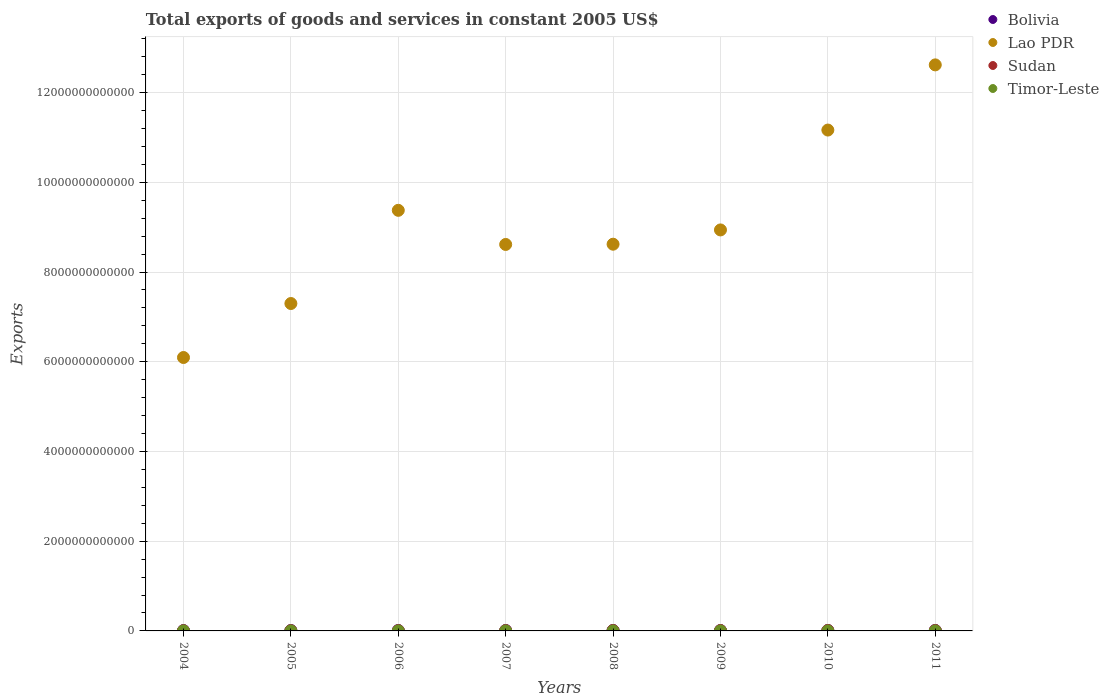Is the number of dotlines equal to the number of legend labels?
Keep it short and to the point. Yes. What is the total exports of goods and services in Bolivia in 2005?
Offer a terse response. 8.91e+09. Across all years, what is the maximum total exports of goods and services in Timor-Leste?
Your answer should be very brief. 9.10e+07. Across all years, what is the minimum total exports of goods and services in Lao PDR?
Your answer should be very brief. 6.09e+12. In which year was the total exports of goods and services in Lao PDR maximum?
Your answer should be very brief. 2011. What is the total total exports of goods and services in Sudan in the graph?
Your answer should be compact. 5.16e+1. What is the difference between the total exports of goods and services in Lao PDR in 2004 and that in 2011?
Make the answer very short. -6.52e+12. What is the difference between the total exports of goods and services in Lao PDR in 2009 and the total exports of goods and services in Sudan in 2008?
Provide a succinct answer. 8.93e+12. What is the average total exports of goods and services in Sudan per year?
Offer a terse response. 6.45e+09. In the year 2006, what is the difference between the total exports of goods and services in Timor-Leste and total exports of goods and services in Lao PDR?
Offer a terse response. -9.37e+12. What is the ratio of the total exports of goods and services in Timor-Leste in 2005 to that in 2008?
Your response must be concise. 0.74. Is the difference between the total exports of goods and services in Timor-Leste in 2007 and 2008 greater than the difference between the total exports of goods and services in Lao PDR in 2007 and 2008?
Offer a very short reply. Yes. What is the difference between the highest and the second highest total exports of goods and services in Timor-Leste?
Your response must be concise. 7.00e+06. What is the difference between the highest and the lowest total exports of goods and services in Timor-Leste?
Ensure brevity in your answer.  4.30e+07. Is the sum of the total exports of goods and services in Bolivia in 2005 and 2006 greater than the maximum total exports of goods and services in Sudan across all years?
Offer a terse response. Yes. Is it the case that in every year, the sum of the total exports of goods and services in Sudan and total exports of goods and services in Timor-Leste  is greater than the total exports of goods and services in Lao PDR?
Make the answer very short. No. Does the total exports of goods and services in Bolivia monotonically increase over the years?
Your response must be concise. No. Is the total exports of goods and services in Lao PDR strictly less than the total exports of goods and services in Bolivia over the years?
Your response must be concise. No. How many years are there in the graph?
Your answer should be compact. 8. What is the difference between two consecutive major ticks on the Y-axis?
Ensure brevity in your answer.  2.00e+12. Are the values on the major ticks of Y-axis written in scientific E-notation?
Offer a very short reply. No. Does the graph contain any zero values?
Provide a succinct answer. No. Does the graph contain grids?
Your response must be concise. Yes. Where does the legend appear in the graph?
Offer a very short reply. Top right. What is the title of the graph?
Ensure brevity in your answer.  Total exports of goods and services in constant 2005 US$. Does "Latvia" appear as one of the legend labels in the graph?
Give a very brief answer. No. What is the label or title of the Y-axis?
Your answer should be compact. Exports. What is the Exports of Bolivia in 2004?
Give a very brief answer. 8.23e+09. What is the Exports of Lao PDR in 2004?
Provide a succinct answer. 6.09e+12. What is the Exports of Sudan in 2004?
Offer a very short reply. 3.97e+09. What is the Exports in Timor-Leste in 2004?
Offer a very short reply. 5.10e+07. What is the Exports in Bolivia in 2005?
Provide a succinct answer. 8.91e+09. What is the Exports in Lao PDR in 2005?
Provide a short and direct response. 7.30e+12. What is the Exports of Sudan in 2005?
Offer a very short reply. 3.98e+09. What is the Exports in Timor-Leste in 2005?
Make the answer very short. 4.80e+07. What is the Exports in Bolivia in 2006?
Give a very brief answer. 9.92e+09. What is the Exports in Lao PDR in 2006?
Offer a terse response. 9.37e+12. What is the Exports of Sudan in 2006?
Provide a short and direct response. 5.32e+09. What is the Exports of Timor-Leste in 2006?
Your response must be concise. 4.90e+07. What is the Exports in Bolivia in 2007?
Provide a short and direct response. 1.02e+1. What is the Exports of Lao PDR in 2007?
Provide a succinct answer. 8.61e+12. What is the Exports in Sudan in 2007?
Give a very brief answer. 6.55e+09. What is the Exports in Timor-Leste in 2007?
Your response must be concise. 6.40e+07. What is the Exports in Bolivia in 2008?
Give a very brief answer. 1.05e+1. What is the Exports of Lao PDR in 2008?
Your response must be concise. 8.62e+12. What is the Exports in Sudan in 2008?
Keep it short and to the point. 8.05e+09. What is the Exports of Timor-Leste in 2008?
Make the answer very short. 6.50e+07. What is the Exports of Bolivia in 2009?
Your answer should be compact. 9.33e+09. What is the Exports in Lao PDR in 2009?
Make the answer very short. 8.94e+12. What is the Exports in Sudan in 2009?
Provide a succinct answer. 7.73e+09. What is the Exports of Timor-Leste in 2009?
Provide a succinct answer. 7.70e+07. What is the Exports of Bolivia in 2010?
Provide a short and direct response. 1.02e+1. What is the Exports of Lao PDR in 2010?
Give a very brief answer. 1.12e+13. What is the Exports of Sudan in 2010?
Your response must be concise. 8.13e+09. What is the Exports of Timor-Leste in 2010?
Provide a short and direct response. 9.10e+07. What is the Exports of Bolivia in 2011?
Offer a very short reply. 1.07e+1. What is the Exports in Lao PDR in 2011?
Your response must be concise. 1.26e+13. What is the Exports in Sudan in 2011?
Offer a very short reply. 7.86e+09. What is the Exports of Timor-Leste in 2011?
Offer a very short reply. 8.40e+07. Across all years, what is the maximum Exports of Bolivia?
Offer a terse response. 1.07e+1. Across all years, what is the maximum Exports of Lao PDR?
Your answer should be compact. 1.26e+13. Across all years, what is the maximum Exports of Sudan?
Provide a succinct answer. 8.13e+09. Across all years, what is the maximum Exports in Timor-Leste?
Offer a terse response. 9.10e+07. Across all years, what is the minimum Exports of Bolivia?
Provide a succinct answer. 8.23e+09. Across all years, what is the minimum Exports of Lao PDR?
Give a very brief answer. 6.09e+12. Across all years, what is the minimum Exports in Sudan?
Make the answer very short. 3.97e+09. Across all years, what is the minimum Exports in Timor-Leste?
Make the answer very short. 4.80e+07. What is the total Exports in Bolivia in the graph?
Offer a very short reply. 7.81e+1. What is the total Exports in Lao PDR in the graph?
Give a very brief answer. 7.27e+13. What is the total Exports in Sudan in the graph?
Your answer should be very brief. 5.16e+1. What is the total Exports in Timor-Leste in the graph?
Provide a succinct answer. 5.29e+08. What is the difference between the Exports of Bolivia in 2004 and that in 2005?
Give a very brief answer. -6.86e+08. What is the difference between the Exports in Lao PDR in 2004 and that in 2005?
Make the answer very short. -1.20e+12. What is the difference between the Exports of Sudan in 2004 and that in 2005?
Keep it short and to the point. -1.63e+07. What is the difference between the Exports of Timor-Leste in 2004 and that in 2005?
Your answer should be compact. 3.00e+06. What is the difference between the Exports of Bolivia in 2004 and that in 2006?
Give a very brief answer. -1.70e+09. What is the difference between the Exports in Lao PDR in 2004 and that in 2006?
Ensure brevity in your answer.  -3.28e+12. What is the difference between the Exports in Sudan in 2004 and that in 2006?
Your answer should be very brief. -1.36e+09. What is the difference between the Exports in Bolivia in 2004 and that in 2007?
Your answer should be very brief. -2.00e+09. What is the difference between the Exports of Lao PDR in 2004 and that in 2007?
Your answer should be compact. -2.52e+12. What is the difference between the Exports of Sudan in 2004 and that in 2007?
Give a very brief answer. -2.58e+09. What is the difference between the Exports of Timor-Leste in 2004 and that in 2007?
Your response must be concise. -1.30e+07. What is the difference between the Exports in Bolivia in 2004 and that in 2008?
Provide a succinct answer. -2.23e+09. What is the difference between the Exports of Lao PDR in 2004 and that in 2008?
Your response must be concise. -2.53e+12. What is the difference between the Exports in Sudan in 2004 and that in 2008?
Offer a terse response. -4.09e+09. What is the difference between the Exports in Timor-Leste in 2004 and that in 2008?
Offer a terse response. -1.40e+07. What is the difference between the Exports of Bolivia in 2004 and that in 2009?
Ensure brevity in your answer.  -1.10e+09. What is the difference between the Exports of Lao PDR in 2004 and that in 2009?
Keep it short and to the point. -2.84e+12. What is the difference between the Exports of Sudan in 2004 and that in 2009?
Offer a terse response. -3.77e+09. What is the difference between the Exports in Timor-Leste in 2004 and that in 2009?
Offer a terse response. -2.60e+07. What is the difference between the Exports in Bolivia in 2004 and that in 2010?
Your response must be concise. -2.02e+09. What is the difference between the Exports in Lao PDR in 2004 and that in 2010?
Your answer should be compact. -5.07e+12. What is the difference between the Exports of Sudan in 2004 and that in 2010?
Your response must be concise. -4.16e+09. What is the difference between the Exports in Timor-Leste in 2004 and that in 2010?
Your response must be concise. -4.00e+07. What is the difference between the Exports in Bolivia in 2004 and that in 2011?
Keep it short and to the point. -2.49e+09. What is the difference between the Exports of Lao PDR in 2004 and that in 2011?
Provide a succinct answer. -6.52e+12. What is the difference between the Exports of Sudan in 2004 and that in 2011?
Keep it short and to the point. -3.89e+09. What is the difference between the Exports in Timor-Leste in 2004 and that in 2011?
Keep it short and to the point. -3.30e+07. What is the difference between the Exports of Bolivia in 2005 and that in 2006?
Your answer should be very brief. -1.01e+09. What is the difference between the Exports of Lao PDR in 2005 and that in 2006?
Your answer should be compact. -2.08e+12. What is the difference between the Exports of Sudan in 2005 and that in 2006?
Ensure brevity in your answer.  -1.34e+09. What is the difference between the Exports in Timor-Leste in 2005 and that in 2006?
Keep it short and to the point. -1.00e+06. What is the difference between the Exports of Bolivia in 2005 and that in 2007?
Make the answer very short. -1.32e+09. What is the difference between the Exports in Lao PDR in 2005 and that in 2007?
Your answer should be very brief. -1.32e+12. What is the difference between the Exports in Sudan in 2005 and that in 2007?
Give a very brief answer. -2.57e+09. What is the difference between the Exports in Timor-Leste in 2005 and that in 2007?
Keep it short and to the point. -1.60e+07. What is the difference between the Exports in Bolivia in 2005 and that in 2008?
Your answer should be compact. -1.54e+09. What is the difference between the Exports of Lao PDR in 2005 and that in 2008?
Give a very brief answer. -1.32e+12. What is the difference between the Exports of Sudan in 2005 and that in 2008?
Offer a very short reply. -4.07e+09. What is the difference between the Exports in Timor-Leste in 2005 and that in 2008?
Keep it short and to the point. -1.70e+07. What is the difference between the Exports in Bolivia in 2005 and that in 2009?
Provide a succinct answer. -4.15e+08. What is the difference between the Exports in Lao PDR in 2005 and that in 2009?
Offer a terse response. -1.64e+12. What is the difference between the Exports of Sudan in 2005 and that in 2009?
Your response must be concise. -3.75e+09. What is the difference between the Exports in Timor-Leste in 2005 and that in 2009?
Provide a short and direct response. -2.90e+07. What is the difference between the Exports in Bolivia in 2005 and that in 2010?
Make the answer very short. -1.33e+09. What is the difference between the Exports in Lao PDR in 2005 and that in 2010?
Provide a succinct answer. -3.87e+12. What is the difference between the Exports in Sudan in 2005 and that in 2010?
Keep it short and to the point. -4.15e+09. What is the difference between the Exports of Timor-Leste in 2005 and that in 2010?
Provide a short and direct response. -4.30e+07. What is the difference between the Exports of Bolivia in 2005 and that in 2011?
Ensure brevity in your answer.  -1.81e+09. What is the difference between the Exports of Lao PDR in 2005 and that in 2011?
Offer a very short reply. -5.32e+12. What is the difference between the Exports of Sudan in 2005 and that in 2011?
Offer a very short reply. -3.88e+09. What is the difference between the Exports of Timor-Leste in 2005 and that in 2011?
Make the answer very short. -3.60e+07. What is the difference between the Exports in Bolivia in 2006 and that in 2007?
Offer a terse response. -3.07e+08. What is the difference between the Exports in Lao PDR in 2006 and that in 2007?
Your answer should be compact. 7.61e+11. What is the difference between the Exports of Sudan in 2006 and that in 2007?
Offer a terse response. -1.23e+09. What is the difference between the Exports of Timor-Leste in 2006 and that in 2007?
Ensure brevity in your answer.  -1.50e+07. What is the difference between the Exports of Bolivia in 2006 and that in 2008?
Make the answer very short. -5.29e+08. What is the difference between the Exports of Lao PDR in 2006 and that in 2008?
Provide a succinct answer. 7.55e+11. What is the difference between the Exports in Sudan in 2006 and that in 2008?
Make the answer very short. -2.73e+09. What is the difference between the Exports of Timor-Leste in 2006 and that in 2008?
Offer a very short reply. -1.60e+07. What is the difference between the Exports of Bolivia in 2006 and that in 2009?
Your response must be concise. 5.95e+08. What is the difference between the Exports in Lao PDR in 2006 and that in 2009?
Offer a terse response. 4.37e+11. What is the difference between the Exports in Sudan in 2006 and that in 2009?
Offer a terse response. -2.41e+09. What is the difference between the Exports in Timor-Leste in 2006 and that in 2009?
Offer a very short reply. -2.80e+07. What is the difference between the Exports of Bolivia in 2006 and that in 2010?
Give a very brief answer. -3.24e+08. What is the difference between the Exports of Lao PDR in 2006 and that in 2010?
Provide a short and direct response. -1.79e+12. What is the difference between the Exports in Sudan in 2006 and that in 2010?
Provide a succinct answer. -2.81e+09. What is the difference between the Exports in Timor-Leste in 2006 and that in 2010?
Your answer should be compact. -4.20e+07. What is the difference between the Exports of Bolivia in 2006 and that in 2011?
Provide a short and direct response. -7.95e+08. What is the difference between the Exports of Lao PDR in 2006 and that in 2011?
Ensure brevity in your answer.  -3.24e+12. What is the difference between the Exports in Sudan in 2006 and that in 2011?
Keep it short and to the point. -2.54e+09. What is the difference between the Exports of Timor-Leste in 2006 and that in 2011?
Provide a succinct answer. -3.50e+07. What is the difference between the Exports in Bolivia in 2007 and that in 2008?
Provide a short and direct response. -2.22e+08. What is the difference between the Exports in Lao PDR in 2007 and that in 2008?
Your response must be concise. -5.55e+09. What is the difference between the Exports in Sudan in 2007 and that in 2008?
Ensure brevity in your answer.  -1.51e+09. What is the difference between the Exports in Bolivia in 2007 and that in 2009?
Offer a very short reply. 9.02e+08. What is the difference between the Exports of Lao PDR in 2007 and that in 2009?
Provide a short and direct response. -3.24e+11. What is the difference between the Exports of Sudan in 2007 and that in 2009?
Provide a succinct answer. -1.18e+09. What is the difference between the Exports in Timor-Leste in 2007 and that in 2009?
Your answer should be very brief. -1.30e+07. What is the difference between the Exports in Bolivia in 2007 and that in 2010?
Your answer should be compact. -1.73e+07. What is the difference between the Exports of Lao PDR in 2007 and that in 2010?
Provide a short and direct response. -2.55e+12. What is the difference between the Exports in Sudan in 2007 and that in 2010?
Give a very brief answer. -1.58e+09. What is the difference between the Exports of Timor-Leste in 2007 and that in 2010?
Give a very brief answer. -2.70e+07. What is the difference between the Exports of Bolivia in 2007 and that in 2011?
Keep it short and to the point. -4.88e+08. What is the difference between the Exports in Lao PDR in 2007 and that in 2011?
Keep it short and to the point. -4.00e+12. What is the difference between the Exports of Sudan in 2007 and that in 2011?
Your answer should be very brief. -1.31e+09. What is the difference between the Exports of Timor-Leste in 2007 and that in 2011?
Your answer should be very brief. -2.00e+07. What is the difference between the Exports of Bolivia in 2008 and that in 2009?
Offer a very short reply. 1.12e+09. What is the difference between the Exports in Lao PDR in 2008 and that in 2009?
Keep it short and to the point. -3.18e+11. What is the difference between the Exports in Sudan in 2008 and that in 2009?
Your answer should be very brief. 3.23e+08. What is the difference between the Exports in Timor-Leste in 2008 and that in 2009?
Your answer should be compact. -1.20e+07. What is the difference between the Exports of Bolivia in 2008 and that in 2010?
Keep it short and to the point. 2.05e+08. What is the difference between the Exports of Lao PDR in 2008 and that in 2010?
Offer a very short reply. -2.54e+12. What is the difference between the Exports in Sudan in 2008 and that in 2010?
Ensure brevity in your answer.  -7.33e+07. What is the difference between the Exports in Timor-Leste in 2008 and that in 2010?
Provide a succinct answer. -2.60e+07. What is the difference between the Exports in Bolivia in 2008 and that in 2011?
Provide a succinct answer. -2.66e+08. What is the difference between the Exports in Lao PDR in 2008 and that in 2011?
Offer a very short reply. -4.00e+12. What is the difference between the Exports of Sudan in 2008 and that in 2011?
Ensure brevity in your answer.  1.95e+08. What is the difference between the Exports of Timor-Leste in 2008 and that in 2011?
Make the answer very short. -1.90e+07. What is the difference between the Exports of Bolivia in 2009 and that in 2010?
Your answer should be compact. -9.19e+08. What is the difference between the Exports of Lao PDR in 2009 and that in 2010?
Your response must be concise. -2.23e+12. What is the difference between the Exports of Sudan in 2009 and that in 2010?
Provide a succinct answer. -3.97e+08. What is the difference between the Exports in Timor-Leste in 2009 and that in 2010?
Offer a very short reply. -1.40e+07. What is the difference between the Exports in Bolivia in 2009 and that in 2011?
Your response must be concise. -1.39e+09. What is the difference between the Exports of Lao PDR in 2009 and that in 2011?
Keep it short and to the point. -3.68e+12. What is the difference between the Exports in Sudan in 2009 and that in 2011?
Provide a short and direct response. -1.28e+08. What is the difference between the Exports of Timor-Leste in 2009 and that in 2011?
Provide a short and direct response. -7.00e+06. What is the difference between the Exports of Bolivia in 2010 and that in 2011?
Your response must be concise. -4.71e+08. What is the difference between the Exports of Lao PDR in 2010 and that in 2011?
Keep it short and to the point. -1.45e+12. What is the difference between the Exports of Sudan in 2010 and that in 2011?
Your answer should be very brief. 2.69e+08. What is the difference between the Exports in Bolivia in 2004 and the Exports in Lao PDR in 2005?
Offer a very short reply. -7.29e+12. What is the difference between the Exports of Bolivia in 2004 and the Exports of Sudan in 2005?
Offer a terse response. 4.25e+09. What is the difference between the Exports of Bolivia in 2004 and the Exports of Timor-Leste in 2005?
Give a very brief answer. 8.18e+09. What is the difference between the Exports in Lao PDR in 2004 and the Exports in Sudan in 2005?
Your answer should be compact. 6.09e+12. What is the difference between the Exports of Lao PDR in 2004 and the Exports of Timor-Leste in 2005?
Your answer should be compact. 6.09e+12. What is the difference between the Exports in Sudan in 2004 and the Exports in Timor-Leste in 2005?
Provide a short and direct response. 3.92e+09. What is the difference between the Exports in Bolivia in 2004 and the Exports in Lao PDR in 2006?
Provide a short and direct response. -9.37e+12. What is the difference between the Exports in Bolivia in 2004 and the Exports in Sudan in 2006?
Make the answer very short. 2.91e+09. What is the difference between the Exports of Bolivia in 2004 and the Exports of Timor-Leste in 2006?
Your response must be concise. 8.18e+09. What is the difference between the Exports of Lao PDR in 2004 and the Exports of Sudan in 2006?
Your answer should be compact. 6.09e+12. What is the difference between the Exports in Lao PDR in 2004 and the Exports in Timor-Leste in 2006?
Give a very brief answer. 6.09e+12. What is the difference between the Exports in Sudan in 2004 and the Exports in Timor-Leste in 2006?
Your response must be concise. 3.92e+09. What is the difference between the Exports of Bolivia in 2004 and the Exports of Lao PDR in 2007?
Provide a succinct answer. -8.61e+12. What is the difference between the Exports of Bolivia in 2004 and the Exports of Sudan in 2007?
Provide a short and direct response. 1.68e+09. What is the difference between the Exports in Bolivia in 2004 and the Exports in Timor-Leste in 2007?
Keep it short and to the point. 8.16e+09. What is the difference between the Exports of Lao PDR in 2004 and the Exports of Sudan in 2007?
Provide a succinct answer. 6.09e+12. What is the difference between the Exports in Lao PDR in 2004 and the Exports in Timor-Leste in 2007?
Your answer should be very brief. 6.09e+12. What is the difference between the Exports of Sudan in 2004 and the Exports of Timor-Leste in 2007?
Your response must be concise. 3.90e+09. What is the difference between the Exports of Bolivia in 2004 and the Exports of Lao PDR in 2008?
Offer a very short reply. -8.61e+12. What is the difference between the Exports of Bolivia in 2004 and the Exports of Sudan in 2008?
Ensure brevity in your answer.  1.74e+08. What is the difference between the Exports in Bolivia in 2004 and the Exports in Timor-Leste in 2008?
Your answer should be compact. 8.16e+09. What is the difference between the Exports of Lao PDR in 2004 and the Exports of Sudan in 2008?
Your answer should be compact. 6.09e+12. What is the difference between the Exports in Lao PDR in 2004 and the Exports in Timor-Leste in 2008?
Your response must be concise. 6.09e+12. What is the difference between the Exports of Sudan in 2004 and the Exports of Timor-Leste in 2008?
Your answer should be very brief. 3.90e+09. What is the difference between the Exports in Bolivia in 2004 and the Exports in Lao PDR in 2009?
Provide a succinct answer. -8.93e+12. What is the difference between the Exports in Bolivia in 2004 and the Exports in Sudan in 2009?
Give a very brief answer. 4.97e+08. What is the difference between the Exports in Bolivia in 2004 and the Exports in Timor-Leste in 2009?
Provide a short and direct response. 8.15e+09. What is the difference between the Exports in Lao PDR in 2004 and the Exports in Sudan in 2009?
Ensure brevity in your answer.  6.09e+12. What is the difference between the Exports of Lao PDR in 2004 and the Exports of Timor-Leste in 2009?
Offer a very short reply. 6.09e+12. What is the difference between the Exports of Sudan in 2004 and the Exports of Timor-Leste in 2009?
Your response must be concise. 3.89e+09. What is the difference between the Exports of Bolivia in 2004 and the Exports of Lao PDR in 2010?
Make the answer very short. -1.12e+13. What is the difference between the Exports in Bolivia in 2004 and the Exports in Sudan in 2010?
Make the answer very short. 1.00e+08. What is the difference between the Exports of Bolivia in 2004 and the Exports of Timor-Leste in 2010?
Give a very brief answer. 8.14e+09. What is the difference between the Exports of Lao PDR in 2004 and the Exports of Sudan in 2010?
Give a very brief answer. 6.09e+12. What is the difference between the Exports of Lao PDR in 2004 and the Exports of Timor-Leste in 2010?
Make the answer very short. 6.09e+12. What is the difference between the Exports of Sudan in 2004 and the Exports of Timor-Leste in 2010?
Make the answer very short. 3.87e+09. What is the difference between the Exports of Bolivia in 2004 and the Exports of Lao PDR in 2011?
Offer a very short reply. -1.26e+13. What is the difference between the Exports in Bolivia in 2004 and the Exports in Sudan in 2011?
Your response must be concise. 3.69e+08. What is the difference between the Exports in Bolivia in 2004 and the Exports in Timor-Leste in 2011?
Ensure brevity in your answer.  8.14e+09. What is the difference between the Exports in Lao PDR in 2004 and the Exports in Sudan in 2011?
Your response must be concise. 6.09e+12. What is the difference between the Exports of Lao PDR in 2004 and the Exports of Timor-Leste in 2011?
Your answer should be very brief. 6.09e+12. What is the difference between the Exports of Sudan in 2004 and the Exports of Timor-Leste in 2011?
Ensure brevity in your answer.  3.88e+09. What is the difference between the Exports in Bolivia in 2005 and the Exports in Lao PDR in 2006?
Offer a terse response. -9.37e+12. What is the difference between the Exports of Bolivia in 2005 and the Exports of Sudan in 2006?
Give a very brief answer. 3.59e+09. What is the difference between the Exports of Bolivia in 2005 and the Exports of Timor-Leste in 2006?
Offer a very short reply. 8.87e+09. What is the difference between the Exports in Lao PDR in 2005 and the Exports in Sudan in 2006?
Your response must be concise. 7.29e+12. What is the difference between the Exports of Lao PDR in 2005 and the Exports of Timor-Leste in 2006?
Give a very brief answer. 7.30e+12. What is the difference between the Exports of Sudan in 2005 and the Exports of Timor-Leste in 2006?
Give a very brief answer. 3.93e+09. What is the difference between the Exports of Bolivia in 2005 and the Exports of Lao PDR in 2007?
Make the answer very short. -8.61e+12. What is the difference between the Exports of Bolivia in 2005 and the Exports of Sudan in 2007?
Offer a terse response. 2.37e+09. What is the difference between the Exports of Bolivia in 2005 and the Exports of Timor-Leste in 2007?
Provide a succinct answer. 8.85e+09. What is the difference between the Exports of Lao PDR in 2005 and the Exports of Sudan in 2007?
Your answer should be compact. 7.29e+12. What is the difference between the Exports in Lao PDR in 2005 and the Exports in Timor-Leste in 2007?
Offer a very short reply. 7.30e+12. What is the difference between the Exports in Sudan in 2005 and the Exports in Timor-Leste in 2007?
Make the answer very short. 3.92e+09. What is the difference between the Exports of Bolivia in 2005 and the Exports of Lao PDR in 2008?
Your response must be concise. -8.61e+12. What is the difference between the Exports in Bolivia in 2005 and the Exports in Sudan in 2008?
Your answer should be compact. 8.60e+08. What is the difference between the Exports of Bolivia in 2005 and the Exports of Timor-Leste in 2008?
Keep it short and to the point. 8.85e+09. What is the difference between the Exports in Lao PDR in 2005 and the Exports in Sudan in 2008?
Give a very brief answer. 7.29e+12. What is the difference between the Exports of Lao PDR in 2005 and the Exports of Timor-Leste in 2008?
Your answer should be very brief. 7.30e+12. What is the difference between the Exports of Sudan in 2005 and the Exports of Timor-Leste in 2008?
Ensure brevity in your answer.  3.92e+09. What is the difference between the Exports of Bolivia in 2005 and the Exports of Lao PDR in 2009?
Provide a short and direct response. -8.93e+12. What is the difference between the Exports of Bolivia in 2005 and the Exports of Sudan in 2009?
Give a very brief answer. 1.18e+09. What is the difference between the Exports in Bolivia in 2005 and the Exports in Timor-Leste in 2009?
Offer a terse response. 8.84e+09. What is the difference between the Exports in Lao PDR in 2005 and the Exports in Sudan in 2009?
Offer a terse response. 7.29e+12. What is the difference between the Exports of Lao PDR in 2005 and the Exports of Timor-Leste in 2009?
Ensure brevity in your answer.  7.30e+12. What is the difference between the Exports in Sudan in 2005 and the Exports in Timor-Leste in 2009?
Offer a terse response. 3.90e+09. What is the difference between the Exports in Bolivia in 2005 and the Exports in Lao PDR in 2010?
Provide a short and direct response. -1.12e+13. What is the difference between the Exports of Bolivia in 2005 and the Exports of Sudan in 2010?
Your answer should be very brief. 7.86e+08. What is the difference between the Exports in Bolivia in 2005 and the Exports in Timor-Leste in 2010?
Your answer should be very brief. 8.82e+09. What is the difference between the Exports in Lao PDR in 2005 and the Exports in Sudan in 2010?
Your answer should be compact. 7.29e+12. What is the difference between the Exports in Lao PDR in 2005 and the Exports in Timor-Leste in 2010?
Your answer should be compact. 7.30e+12. What is the difference between the Exports in Sudan in 2005 and the Exports in Timor-Leste in 2010?
Give a very brief answer. 3.89e+09. What is the difference between the Exports in Bolivia in 2005 and the Exports in Lao PDR in 2011?
Provide a short and direct response. -1.26e+13. What is the difference between the Exports of Bolivia in 2005 and the Exports of Sudan in 2011?
Ensure brevity in your answer.  1.05e+09. What is the difference between the Exports in Bolivia in 2005 and the Exports in Timor-Leste in 2011?
Provide a succinct answer. 8.83e+09. What is the difference between the Exports of Lao PDR in 2005 and the Exports of Sudan in 2011?
Your response must be concise. 7.29e+12. What is the difference between the Exports in Lao PDR in 2005 and the Exports in Timor-Leste in 2011?
Make the answer very short. 7.30e+12. What is the difference between the Exports in Sudan in 2005 and the Exports in Timor-Leste in 2011?
Give a very brief answer. 3.90e+09. What is the difference between the Exports in Bolivia in 2006 and the Exports in Lao PDR in 2007?
Provide a short and direct response. -8.60e+12. What is the difference between the Exports in Bolivia in 2006 and the Exports in Sudan in 2007?
Keep it short and to the point. 3.38e+09. What is the difference between the Exports of Bolivia in 2006 and the Exports of Timor-Leste in 2007?
Offer a terse response. 9.86e+09. What is the difference between the Exports in Lao PDR in 2006 and the Exports in Sudan in 2007?
Keep it short and to the point. 9.37e+12. What is the difference between the Exports in Lao PDR in 2006 and the Exports in Timor-Leste in 2007?
Ensure brevity in your answer.  9.37e+12. What is the difference between the Exports of Sudan in 2006 and the Exports of Timor-Leste in 2007?
Provide a succinct answer. 5.26e+09. What is the difference between the Exports in Bolivia in 2006 and the Exports in Lao PDR in 2008?
Provide a succinct answer. -8.61e+12. What is the difference between the Exports of Bolivia in 2006 and the Exports of Sudan in 2008?
Offer a very short reply. 1.87e+09. What is the difference between the Exports of Bolivia in 2006 and the Exports of Timor-Leste in 2008?
Provide a succinct answer. 9.86e+09. What is the difference between the Exports of Lao PDR in 2006 and the Exports of Sudan in 2008?
Your answer should be compact. 9.37e+12. What is the difference between the Exports in Lao PDR in 2006 and the Exports in Timor-Leste in 2008?
Offer a very short reply. 9.37e+12. What is the difference between the Exports in Sudan in 2006 and the Exports in Timor-Leste in 2008?
Give a very brief answer. 5.26e+09. What is the difference between the Exports of Bolivia in 2006 and the Exports of Lao PDR in 2009?
Provide a succinct answer. -8.93e+12. What is the difference between the Exports in Bolivia in 2006 and the Exports in Sudan in 2009?
Ensure brevity in your answer.  2.19e+09. What is the difference between the Exports in Bolivia in 2006 and the Exports in Timor-Leste in 2009?
Your answer should be compact. 9.85e+09. What is the difference between the Exports of Lao PDR in 2006 and the Exports of Sudan in 2009?
Your answer should be very brief. 9.37e+12. What is the difference between the Exports of Lao PDR in 2006 and the Exports of Timor-Leste in 2009?
Ensure brevity in your answer.  9.37e+12. What is the difference between the Exports of Sudan in 2006 and the Exports of Timor-Leste in 2009?
Give a very brief answer. 5.24e+09. What is the difference between the Exports in Bolivia in 2006 and the Exports in Lao PDR in 2010?
Provide a succinct answer. -1.12e+13. What is the difference between the Exports of Bolivia in 2006 and the Exports of Sudan in 2010?
Offer a very short reply. 1.80e+09. What is the difference between the Exports of Bolivia in 2006 and the Exports of Timor-Leste in 2010?
Your answer should be very brief. 9.83e+09. What is the difference between the Exports in Lao PDR in 2006 and the Exports in Sudan in 2010?
Make the answer very short. 9.37e+12. What is the difference between the Exports of Lao PDR in 2006 and the Exports of Timor-Leste in 2010?
Provide a succinct answer. 9.37e+12. What is the difference between the Exports of Sudan in 2006 and the Exports of Timor-Leste in 2010?
Provide a short and direct response. 5.23e+09. What is the difference between the Exports in Bolivia in 2006 and the Exports in Lao PDR in 2011?
Offer a very short reply. -1.26e+13. What is the difference between the Exports of Bolivia in 2006 and the Exports of Sudan in 2011?
Provide a succinct answer. 2.07e+09. What is the difference between the Exports in Bolivia in 2006 and the Exports in Timor-Leste in 2011?
Provide a succinct answer. 9.84e+09. What is the difference between the Exports in Lao PDR in 2006 and the Exports in Sudan in 2011?
Your answer should be very brief. 9.37e+12. What is the difference between the Exports in Lao PDR in 2006 and the Exports in Timor-Leste in 2011?
Provide a succinct answer. 9.37e+12. What is the difference between the Exports in Sudan in 2006 and the Exports in Timor-Leste in 2011?
Offer a terse response. 5.24e+09. What is the difference between the Exports in Bolivia in 2007 and the Exports in Lao PDR in 2008?
Ensure brevity in your answer.  -8.61e+12. What is the difference between the Exports of Bolivia in 2007 and the Exports of Sudan in 2008?
Provide a short and direct response. 2.18e+09. What is the difference between the Exports in Bolivia in 2007 and the Exports in Timor-Leste in 2008?
Make the answer very short. 1.02e+1. What is the difference between the Exports of Lao PDR in 2007 and the Exports of Sudan in 2008?
Provide a succinct answer. 8.61e+12. What is the difference between the Exports of Lao PDR in 2007 and the Exports of Timor-Leste in 2008?
Make the answer very short. 8.61e+12. What is the difference between the Exports in Sudan in 2007 and the Exports in Timor-Leste in 2008?
Your response must be concise. 6.48e+09. What is the difference between the Exports of Bolivia in 2007 and the Exports of Lao PDR in 2009?
Keep it short and to the point. -8.93e+12. What is the difference between the Exports of Bolivia in 2007 and the Exports of Sudan in 2009?
Provide a short and direct response. 2.50e+09. What is the difference between the Exports in Bolivia in 2007 and the Exports in Timor-Leste in 2009?
Make the answer very short. 1.02e+1. What is the difference between the Exports in Lao PDR in 2007 and the Exports in Sudan in 2009?
Keep it short and to the point. 8.61e+12. What is the difference between the Exports of Lao PDR in 2007 and the Exports of Timor-Leste in 2009?
Keep it short and to the point. 8.61e+12. What is the difference between the Exports in Sudan in 2007 and the Exports in Timor-Leste in 2009?
Make the answer very short. 6.47e+09. What is the difference between the Exports in Bolivia in 2007 and the Exports in Lao PDR in 2010?
Ensure brevity in your answer.  -1.12e+13. What is the difference between the Exports in Bolivia in 2007 and the Exports in Sudan in 2010?
Offer a terse response. 2.10e+09. What is the difference between the Exports of Bolivia in 2007 and the Exports of Timor-Leste in 2010?
Keep it short and to the point. 1.01e+1. What is the difference between the Exports in Lao PDR in 2007 and the Exports in Sudan in 2010?
Your answer should be compact. 8.61e+12. What is the difference between the Exports of Lao PDR in 2007 and the Exports of Timor-Leste in 2010?
Offer a very short reply. 8.61e+12. What is the difference between the Exports in Sudan in 2007 and the Exports in Timor-Leste in 2010?
Ensure brevity in your answer.  6.46e+09. What is the difference between the Exports in Bolivia in 2007 and the Exports in Lao PDR in 2011?
Ensure brevity in your answer.  -1.26e+13. What is the difference between the Exports of Bolivia in 2007 and the Exports of Sudan in 2011?
Your answer should be very brief. 2.37e+09. What is the difference between the Exports of Bolivia in 2007 and the Exports of Timor-Leste in 2011?
Provide a short and direct response. 1.01e+1. What is the difference between the Exports of Lao PDR in 2007 and the Exports of Sudan in 2011?
Your answer should be compact. 8.61e+12. What is the difference between the Exports in Lao PDR in 2007 and the Exports in Timor-Leste in 2011?
Give a very brief answer. 8.61e+12. What is the difference between the Exports in Sudan in 2007 and the Exports in Timor-Leste in 2011?
Offer a very short reply. 6.46e+09. What is the difference between the Exports of Bolivia in 2008 and the Exports of Lao PDR in 2009?
Make the answer very short. -8.93e+12. What is the difference between the Exports in Bolivia in 2008 and the Exports in Sudan in 2009?
Your answer should be very brief. 2.72e+09. What is the difference between the Exports in Bolivia in 2008 and the Exports in Timor-Leste in 2009?
Your answer should be compact. 1.04e+1. What is the difference between the Exports of Lao PDR in 2008 and the Exports of Sudan in 2009?
Give a very brief answer. 8.61e+12. What is the difference between the Exports of Lao PDR in 2008 and the Exports of Timor-Leste in 2009?
Ensure brevity in your answer.  8.62e+12. What is the difference between the Exports of Sudan in 2008 and the Exports of Timor-Leste in 2009?
Your answer should be compact. 7.98e+09. What is the difference between the Exports in Bolivia in 2008 and the Exports in Lao PDR in 2010?
Offer a terse response. -1.12e+13. What is the difference between the Exports in Bolivia in 2008 and the Exports in Sudan in 2010?
Provide a short and direct response. 2.33e+09. What is the difference between the Exports of Bolivia in 2008 and the Exports of Timor-Leste in 2010?
Keep it short and to the point. 1.04e+1. What is the difference between the Exports of Lao PDR in 2008 and the Exports of Sudan in 2010?
Keep it short and to the point. 8.61e+12. What is the difference between the Exports of Lao PDR in 2008 and the Exports of Timor-Leste in 2010?
Offer a terse response. 8.62e+12. What is the difference between the Exports of Sudan in 2008 and the Exports of Timor-Leste in 2010?
Give a very brief answer. 7.96e+09. What is the difference between the Exports of Bolivia in 2008 and the Exports of Lao PDR in 2011?
Keep it short and to the point. -1.26e+13. What is the difference between the Exports in Bolivia in 2008 and the Exports in Sudan in 2011?
Offer a very short reply. 2.59e+09. What is the difference between the Exports of Bolivia in 2008 and the Exports of Timor-Leste in 2011?
Give a very brief answer. 1.04e+1. What is the difference between the Exports in Lao PDR in 2008 and the Exports in Sudan in 2011?
Your answer should be very brief. 8.61e+12. What is the difference between the Exports in Lao PDR in 2008 and the Exports in Timor-Leste in 2011?
Ensure brevity in your answer.  8.62e+12. What is the difference between the Exports in Sudan in 2008 and the Exports in Timor-Leste in 2011?
Provide a succinct answer. 7.97e+09. What is the difference between the Exports in Bolivia in 2009 and the Exports in Lao PDR in 2010?
Provide a succinct answer. -1.12e+13. What is the difference between the Exports of Bolivia in 2009 and the Exports of Sudan in 2010?
Your answer should be very brief. 1.20e+09. What is the difference between the Exports of Bolivia in 2009 and the Exports of Timor-Leste in 2010?
Your response must be concise. 9.24e+09. What is the difference between the Exports in Lao PDR in 2009 and the Exports in Sudan in 2010?
Give a very brief answer. 8.93e+12. What is the difference between the Exports of Lao PDR in 2009 and the Exports of Timor-Leste in 2010?
Offer a terse response. 8.94e+12. What is the difference between the Exports of Sudan in 2009 and the Exports of Timor-Leste in 2010?
Offer a very short reply. 7.64e+09. What is the difference between the Exports in Bolivia in 2009 and the Exports in Lao PDR in 2011?
Your response must be concise. -1.26e+13. What is the difference between the Exports in Bolivia in 2009 and the Exports in Sudan in 2011?
Give a very brief answer. 1.47e+09. What is the difference between the Exports of Bolivia in 2009 and the Exports of Timor-Leste in 2011?
Keep it short and to the point. 9.25e+09. What is the difference between the Exports in Lao PDR in 2009 and the Exports in Sudan in 2011?
Your answer should be compact. 8.93e+12. What is the difference between the Exports of Lao PDR in 2009 and the Exports of Timor-Leste in 2011?
Provide a short and direct response. 8.94e+12. What is the difference between the Exports of Sudan in 2009 and the Exports of Timor-Leste in 2011?
Your answer should be very brief. 7.65e+09. What is the difference between the Exports of Bolivia in 2010 and the Exports of Lao PDR in 2011?
Your answer should be very brief. -1.26e+13. What is the difference between the Exports in Bolivia in 2010 and the Exports in Sudan in 2011?
Offer a very short reply. 2.39e+09. What is the difference between the Exports of Bolivia in 2010 and the Exports of Timor-Leste in 2011?
Ensure brevity in your answer.  1.02e+1. What is the difference between the Exports in Lao PDR in 2010 and the Exports in Sudan in 2011?
Offer a terse response. 1.12e+13. What is the difference between the Exports in Lao PDR in 2010 and the Exports in Timor-Leste in 2011?
Your response must be concise. 1.12e+13. What is the difference between the Exports of Sudan in 2010 and the Exports of Timor-Leste in 2011?
Provide a short and direct response. 8.04e+09. What is the average Exports in Bolivia per year?
Make the answer very short. 9.76e+09. What is the average Exports in Lao PDR per year?
Give a very brief answer. 9.09e+12. What is the average Exports of Sudan per year?
Your answer should be compact. 6.45e+09. What is the average Exports in Timor-Leste per year?
Give a very brief answer. 6.61e+07. In the year 2004, what is the difference between the Exports of Bolivia and Exports of Lao PDR?
Give a very brief answer. -6.09e+12. In the year 2004, what is the difference between the Exports of Bolivia and Exports of Sudan?
Your answer should be compact. 4.26e+09. In the year 2004, what is the difference between the Exports of Bolivia and Exports of Timor-Leste?
Ensure brevity in your answer.  8.18e+09. In the year 2004, what is the difference between the Exports of Lao PDR and Exports of Sudan?
Provide a short and direct response. 6.09e+12. In the year 2004, what is the difference between the Exports in Lao PDR and Exports in Timor-Leste?
Your answer should be compact. 6.09e+12. In the year 2004, what is the difference between the Exports in Sudan and Exports in Timor-Leste?
Ensure brevity in your answer.  3.91e+09. In the year 2005, what is the difference between the Exports of Bolivia and Exports of Lao PDR?
Offer a terse response. -7.29e+12. In the year 2005, what is the difference between the Exports in Bolivia and Exports in Sudan?
Keep it short and to the point. 4.93e+09. In the year 2005, what is the difference between the Exports in Bolivia and Exports in Timor-Leste?
Keep it short and to the point. 8.87e+09. In the year 2005, what is the difference between the Exports of Lao PDR and Exports of Sudan?
Ensure brevity in your answer.  7.29e+12. In the year 2005, what is the difference between the Exports of Lao PDR and Exports of Timor-Leste?
Ensure brevity in your answer.  7.30e+12. In the year 2005, what is the difference between the Exports of Sudan and Exports of Timor-Leste?
Provide a short and direct response. 3.93e+09. In the year 2006, what is the difference between the Exports in Bolivia and Exports in Lao PDR?
Your answer should be compact. -9.37e+12. In the year 2006, what is the difference between the Exports in Bolivia and Exports in Sudan?
Your answer should be compact. 4.60e+09. In the year 2006, what is the difference between the Exports of Bolivia and Exports of Timor-Leste?
Keep it short and to the point. 9.88e+09. In the year 2006, what is the difference between the Exports in Lao PDR and Exports in Sudan?
Ensure brevity in your answer.  9.37e+12. In the year 2006, what is the difference between the Exports of Lao PDR and Exports of Timor-Leste?
Your answer should be very brief. 9.37e+12. In the year 2006, what is the difference between the Exports in Sudan and Exports in Timor-Leste?
Provide a succinct answer. 5.27e+09. In the year 2007, what is the difference between the Exports of Bolivia and Exports of Lao PDR?
Keep it short and to the point. -8.60e+12. In the year 2007, what is the difference between the Exports of Bolivia and Exports of Sudan?
Ensure brevity in your answer.  3.68e+09. In the year 2007, what is the difference between the Exports in Bolivia and Exports in Timor-Leste?
Your response must be concise. 1.02e+1. In the year 2007, what is the difference between the Exports in Lao PDR and Exports in Sudan?
Make the answer very short. 8.61e+12. In the year 2007, what is the difference between the Exports of Lao PDR and Exports of Timor-Leste?
Ensure brevity in your answer.  8.61e+12. In the year 2007, what is the difference between the Exports of Sudan and Exports of Timor-Leste?
Offer a terse response. 6.48e+09. In the year 2008, what is the difference between the Exports in Bolivia and Exports in Lao PDR?
Offer a terse response. -8.61e+12. In the year 2008, what is the difference between the Exports in Bolivia and Exports in Sudan?
Your answer should be compact. 2.40e+09. In the year 2008, what is the difference between the Exports in Bolivia and Exports in Timor-Leste?
Provide a succinct answer. 1.04e+1. In the year 2008, what is the difference between the Exports of Lao PDR and Exports of Sudan?
Give a very brief answer. 8.61e+12. In the year 2008, what is the difference between the Exports of Lao PDR and Exports of Timor-Leste?
Provide a succinct answer. 8.62e+12. In the year 2008, what is the difference between the Exports in Sudan and Exports in Timor-Leste?
Offer a very short reply. 7.99e+09. In the year 2009, what is the difference between the Exports of Bolivia and Exports of Lao PDR?
Your answer should be very brief. -8.93e+12. In the year 2009, what is the difference between the Exports of Bolivia and Exports of Sudan?
Make the answer very short. 1.60e+09. In the year 2009, what is the difference between the Exports in Bolivia and Exports in Timor-Leste?
Offer a terse response. 9.25e+09. In the year 2009, what is the difference between the Exports of Lao PDR and Exports of Sudan?
Offer a very short reply. 8.93e+12. In the year 2009, what is the difference between the Exports of Lao PDR and Exports of Timor-Leste?
Your answer should be very brief. 8.94e+12. In the year 2009, what is the difference between the Exports in Sudan and Exports in Timor-Leste?
Your answer should be compact. 7.65e+09. In the year 2010, what is the difference between the Exports of Bolivia and Exports of Lao PDR?
Offer a terse response. -1.12e+13. In the year 2010, what is the difference between the Exports in Bolivia and Exports in Sudan?
Offer a very short reply. 2.12e+09. In the year 2010, what is the difference between the Exports of Bolivia and Exports of Timor-Leste?
Offer a very short reply. 1.02e+1. In the year 2010, what is the difference between the Exports of Lao PDR and Exports of Sudan?
Offer a terse response. 1.12e+13. In the year 2010, what is the difference between the Exports of Lao PDR and Exports of Timor-Leste?
Your answer should be compact. 1.12e+13. In the year 2010, what is the difference between the Exports in Sudan and Exports in Timor-Leste?
Give a very brief answer. 8.04e+09. In the year 2011, what is the difference between the Exports in Bolivia and Exports in Lao PDR?
Offer a terse response. -1.26e+13. In the year 2011, what is the difference between the Exports of Bolivia and Exports of Sudan?
Your response must be concise. 2.86e+09. In the year 2011, what is the difference between the Exports in Bolivia and Exports in Timor-Leste?
Your response must be concise. 1.06e+1. In the year 2011, what is the difference between the Exports in Lao PDR and Exports in Sudan?
Your response must be concise. 1.26e+13. In the year 2011, what is the difference between the Exports in Lao PDR and Exports in Timor-Leste?
Provide a short and direct response. 1.26e+13. In the year 2011, what is the difference between the Exports in Sudan and Exports in Timor-Leste?
Ensure brevity in your answer.  7.78e+09. What is the ratio of the Exports of Bolivia in 2004 to that in 2005?
Make the answer very short. 0.92. What is the ratio of the Exports of Lao PDR in 2004 to that in 2005?
Give a very brief answer. 0.84. What is the ratio of the Exports in Bolivia in 2004 to that in 2006?
Make the answer very short. 0.83. What is the ratio of the Exports of Lao PDR in 2004 to that in 2006?
Give a very brief answer. 0.65. What is the ratio of the Exports of Sudan in 2004 to that in 2006?
Provide a short and direct response. 0.75. What is the ratio of the Exports of Timor-Leste in 2004 to that in 2006?
Provide a short and direct response. 1.04. What is the ratio of the Exports in Bolivia in 2004 to that in 2007?
Keep it short and to the point. 0.8. What is the ratio of the Exports of Lao PDR in 2004 to that in 2007?
Make the answer very short. 0.71. What is the ratio of the Exports of Sudan in 2004 to that in 2007?
Make the answer very short. 0.61. What is the ratio of the Exports of Timor-Leste in 2004 to that in 2007?
Provide a short and direct response. 0.8. What is the ratio of the Exports in Bolivia in 2004 to that in 2008?
Give a very brief answer. 0.79. What is the ratio of the Exports in Lao PDR in 2004 to that in 2008?
Your response must be concise. 0.71. What is the ratio of the Exports in Sudan in 2004 to that in 2008?
Your response must be concise. 0.49. What is the ratio of the Exports in Timor-Leste in 2004 to that in 2008?
Give a very brief answer. 0.78. What is the ratio of the Exports of Bolivia in 2004 to that in 2009?
Keep it short and to the point. 0.88. What is the ratio of the Exports in Lao PDR in 2004 to that in 2009?
Offer a very short reply. 0.68. What is the ratio of the Exports of Sudan in 2004 to that in 2009?
Your answer should be very brief. 0.51. What is the ratio of the Exports in Timor-Leste in 2004 to that in 2009?
Make the answer very short. 0.66. What is the ratio of the Exports of Bolivia in 2004 to that in 2010?
Ensure brevity in your answer.  0.8. What is the ratio of the Exports of Lao PDR in 2004 to that in 2010?
Offer a terse response. 0.55. What is the ratio of the Exports of Sudan in 2004 to that in 2010?
Offer a very short reply. 0.49. What is the ratio of the Exports of Timor-Leste in 2004 to that in 2010?
Provide a succinct answer. 0.56. What is the ratio of the Exports in Bolivia in 2004 to that in 2011?
Your response must be concise. 0.77. What is the ratio of the Exports in Lao PDR in 2004 to that in 2011?
Give a very brief answer. 0.48. What is the ratio of the Exports in Sudan in 2004 to that in 2011?
Your answer should be very brief. 0.5. What is the ratio of the Exports of Timor-Leste in 2004 to that in 2011?
Make the answer very short. 0.61. What is the ratio of the Exports of Bolivia in 2005 to that in 2006?
Give a very brief answer. 0.9. What is the ratio of the Exports of Lao PDR in 2005 to that in 2006?
Ensure brevity in your answer.  0.78. What is the ratio of the Exports in Sudan in 2005 to that in 2006?
Keep it short and to the point. 0.75. What is the ratio of the Exports of Timor-Leste in 2005 to that in 2006?
Your response must be concise. 0.98. What is the ratio of the Exports of Bolivia in 2005 to that in 2007?
Offer a terse response. 0.87. What is the ratio of the Exports in Lao PDR in 2005 to that in 2007?
Make the answer very short. 0.85. What is the ratio of the Exports in Sudan in 2005 to that in 2007?
Make the answer very short. 0.61. What is the ratio of the Exports of Timor-Leste in 2005 to that in 2007?
Provide a succinct answer. 0.75. What is the ratio of the Exports in Bolivia in 2005 to that in 2008?
Your answer should be very brief. 0.85. What is the ratio of the Exports in Lao PDR in 2005 to that in 2008?
Your answer should be very brief. 0.85. What is the ratio of the Exports in Sudan in 2005 to that in 2008?
Offer a very short reply. 0.49. What is the ratio of the Exports of Timor-Leste in 2005 to that in 2008?
Give a very brief answer. 0.74. What is the ratio of the Exports of Bolivia in 2005 to that in 2009?
Your response must be concise. 0.96. What is the ratio of the Exports in Lao PDR in 2005 to that in 2009?
Provide a short and direct response. 0.82. What is the ratio of the Exports of Sudan in 2005 to that in 2009?
Provide a short and direct response. 0.52. What is the ratio of the Exports of Timor-Leste in 2005 to that in 2009?
Give a very brief answer. 0.62. What is the ratio of the Exports of Bolivia in 2005 to that in 2010?
Your answer should be very brief. 0.87. What is the ratio of the Exports in Lao PDR in 2005 to that in 2010?
Provide a short and direct response. 0.65. What is the ratio of the Exports of Sudan in 2005 to that in 2010?
Provide a succinct answer. 0.49. What is the ratio of the Exports in Timor-Leste in 2005 to that in 2010?
Keep it short and to the point. 0.53. What is the ratio of the Exports of Bolivia in 2005 to that in 2011?
Provide a short and direct response. 0.83. What is the ratio of the Exports in Lao PDR in 2005 to that in 2011?
Ensure brevity in your answer.  0.58. What is the ratio of the Exports of Sudan in 2005 to that in 2011?
Your response must be concise. 0.51. What is the ratio of the Exports of Timor-Leste in 2005 to that in 2011?
Your answer should be very brief. 0.57. What is the ratio of the Exports in Lao PDR in 2006 to that in 2007?
Keep it short and to the point. 1.09. What is the ratio of the Exports in Sudan in 2006 to that in 2007?
Your answer should be very brief. 0.81. What is the ratio of the Exports of Timor-Leste in 2006 to that in 2007?
Ensure brevity in your answer.  0.77. What is the ratio of the Exports of Bolivia in 2006 to that in 2008?
Offer a very short reply. 0.95. What is the ratio of the Exports of Lao PDR in 2006 to that in 2008?
Offer a very short reply. 1.09. What is the ratio of the Exports of Sudan in 2006 to that in 2008?
Ensure brevity in your answer.  0.66. What is the ratio of the Exports of Timor-Leste in 2006 to that in 2008?
Your answer should be very brief. 0.75. What is the ratio of the Exports of Bolivia in 2006 to that in 2009?
Keep it short and to the point. 1.06. What is the ratio of the Exports in Lao PDR in 2006 to that in 2009?
Provide a succinct answer. 1.05. What is the ratio of the Exports of Sudan in 2006 to that in 2009?
Give a very brief answer. 0.69. What is the ratio of the Exports of Timor-Leste in 2006 to that in 2009?
Provide a succinct answer. 0.64. What is the ratio of the Exports in Bolivia in 2006 to that in 2010?
Offer a terse response. 0.97. What is the ratio of the Exports in Lao PDR in 2006 to that in 2010?
Offer a terse response. 0.84. What is the ratio of the Exports of Sudan in 2006 to that in 2010?
Provide a succinct answer. 0.65. What is the ratio of the Exports in Timor-Leste in 2006 to that in 2010?
Keep it short and to the point. 0.54. What is the ratio of the Exports of Bolivia in 2006 to that in 2011?
Offer a very short reply. 0.93. What is the ratio of the Exports in Lao PDR in 2006 to that in 2011?
Your answer should be compact. 0.74. What is the ratio of the Exports of Sudan in 2006 to that in 2011?
Provide a short and direct response. 0.68. What is the ratio of the Exports of Timor-Leste in 2006 to that in 2011?
Make the answer very short. 0.58. What is the ratio of the Exports in Bolivia in 2007 to that in 2008?
Your answer should be compact. 0.98. What is the ratio of the Exports of Sudan in 2007 to that in 2008?
Offer a very short reply. 0.81. What is the ratio of the Exports in Timor-Leste in 2007 to that in 2008?
Give a very brief answer. 0.98. What is the ratio of the Exports in Bolivia in 2007 to that in 2009?
Provide a succinct answer. 1.1. What is the ratio of the Exports in Lao PDR in 2007 to that in 2009?
Keep it short and to the point. 0.96. What is the ratio of the Exports in Sudan in 2007 to that in 2009?
Your answer should be compact. 0.85. What is the ratio of the Exports in Timor-Leste in 2007 to that in 2009?
Make the answer very short. 0.83. What is the ratio of the Exports in Lao PDR in 2007 to that in 2010?
Offer a terse response. 0.77. What is the ratio of the Exports of Sudan in 2007 to that in 2010?
Make the answer very short. 0.81. What is the ratio of the Exports in Timor-Leste in 2007 to that in 2010?
Provide a succinct answer. 0.7. What is the ratio of the Exports in Bolivia in 2007 to that in 2011?
Give a very brief answer. 0.95. What is the ratio of the Exports in Lao PDR in 2007 to that in 2011?
Keep it short and to the point. 0.68. What is the ratio of the Exports in Sudan in 2007 to that in 2011?
Keep it short and to the point. 0.83. What is the ratio of the Exports of Timor-Leste in 2007 to that in 2011?
Make the answer very short. 0.76. What is the ratio of the Exports in Bolivia in 2008 to that in 2009?
Your response must be concise. 1.12. What is the ratio of the Exports of Lao PDR in 2008 to that in 2009?
Offer a very short reply. 0.96. What is the ratio of the Exports in Sudan in 2008 to that in 2009?
Offer a very short reply. 1.04. What is the ratio of the Exports in Timor-Leste in 2008 to that in 2009?
Your answer should be compact. 0.84. What is the ratio of the Exports of Lao PDR in 2008 to that in 2010?
Provide a short and direct response. 0.77. What is the ratio of the Exports of Bolivia in 2008 to that in 2011?
Ensure brevity in your answer.  0.98. What is the ratio of the Exports in Lao PDR in 2008 to that in 2011?
Your answer should be compact. 0.68. What is the ratio of the Exports of Sudan in 2008 to that in 2011?
Your response must be concise. 1.02. What is the ratio of the Exports in Timor-Leste in 2008 to that in 2011?
Offer a very short reply. 0.77. What is the ratio of the Exports of Bolivia in 2009 to that in 2010?
Give a very brief answer. 0.91. What is the ratio of the Exports of Lao PDR in 2009 to that in 2010?
Your response must be concise. 0.8. What is the ratio of the Exports of Sudan in 2009 to that in 2010?
Give a very brief answer. 0.95. What is the ratio of the Exports in Timor-Leste in 2009 to that in 2010?
Offer a terse response. 0.85. What is the ratio of the Exports of Bolivia in 2009 to that in 2011?
Give a very brief answer. 0.87. What is the ratio of the Exports in Lao PDR in 2009 to that in 2011?
Give a very brief answer. 0.71. What is the ratio of the Exports in Sudan in 2009 to that in 2011?
Your answer should be very brief. 0.98. What is the ratio of the Exports in Timor-Leste in 2009 to that in 2011?
Provide a short and direct response. 0.92. What is the ratio of the Exports of Bolivia in 2010 to that in 2011?
Offer a very short reply. 0.96. What is the ratio of the Exports in Lao PDR in 2010 to that in 2011?
Make the answer very short. 0.88. What is the ratio of the Exports of Sudan in 2010 to that in 2011?
Give a very brief answer. 1.03. What is the difference between the highest and the second highest Exports in Bolivia?
Provide a succinct answer. 2.66e+08. What is the difference between the highest and the second highest Exports of Lao PDR?
Provide a short and direct response. 1.45e+12. What is the difference between the highest and the second highest Exports of Sudan?
Your answer should be compact. 7.33e+07. What is the difference between the highest and the second highest Exports in Timor-Leste?
Provide a succinct answer. 7.00e+06. What is the difference between the highest and the lowest Exports of Bolivia?
Make the answer very short. 2.49e+09. What is the difference between the highest and the lowest Exports of Lao PDR?
Your response must be concise. 6.52e+12. What is the difference between the highest and the lowest Exports of Sudan?
Make the answer very short. 4.16e+09. What is the difference between the highest and the lowest Exports in Timor-Leste?
Provide a succinct answer. 4.30e+07. 